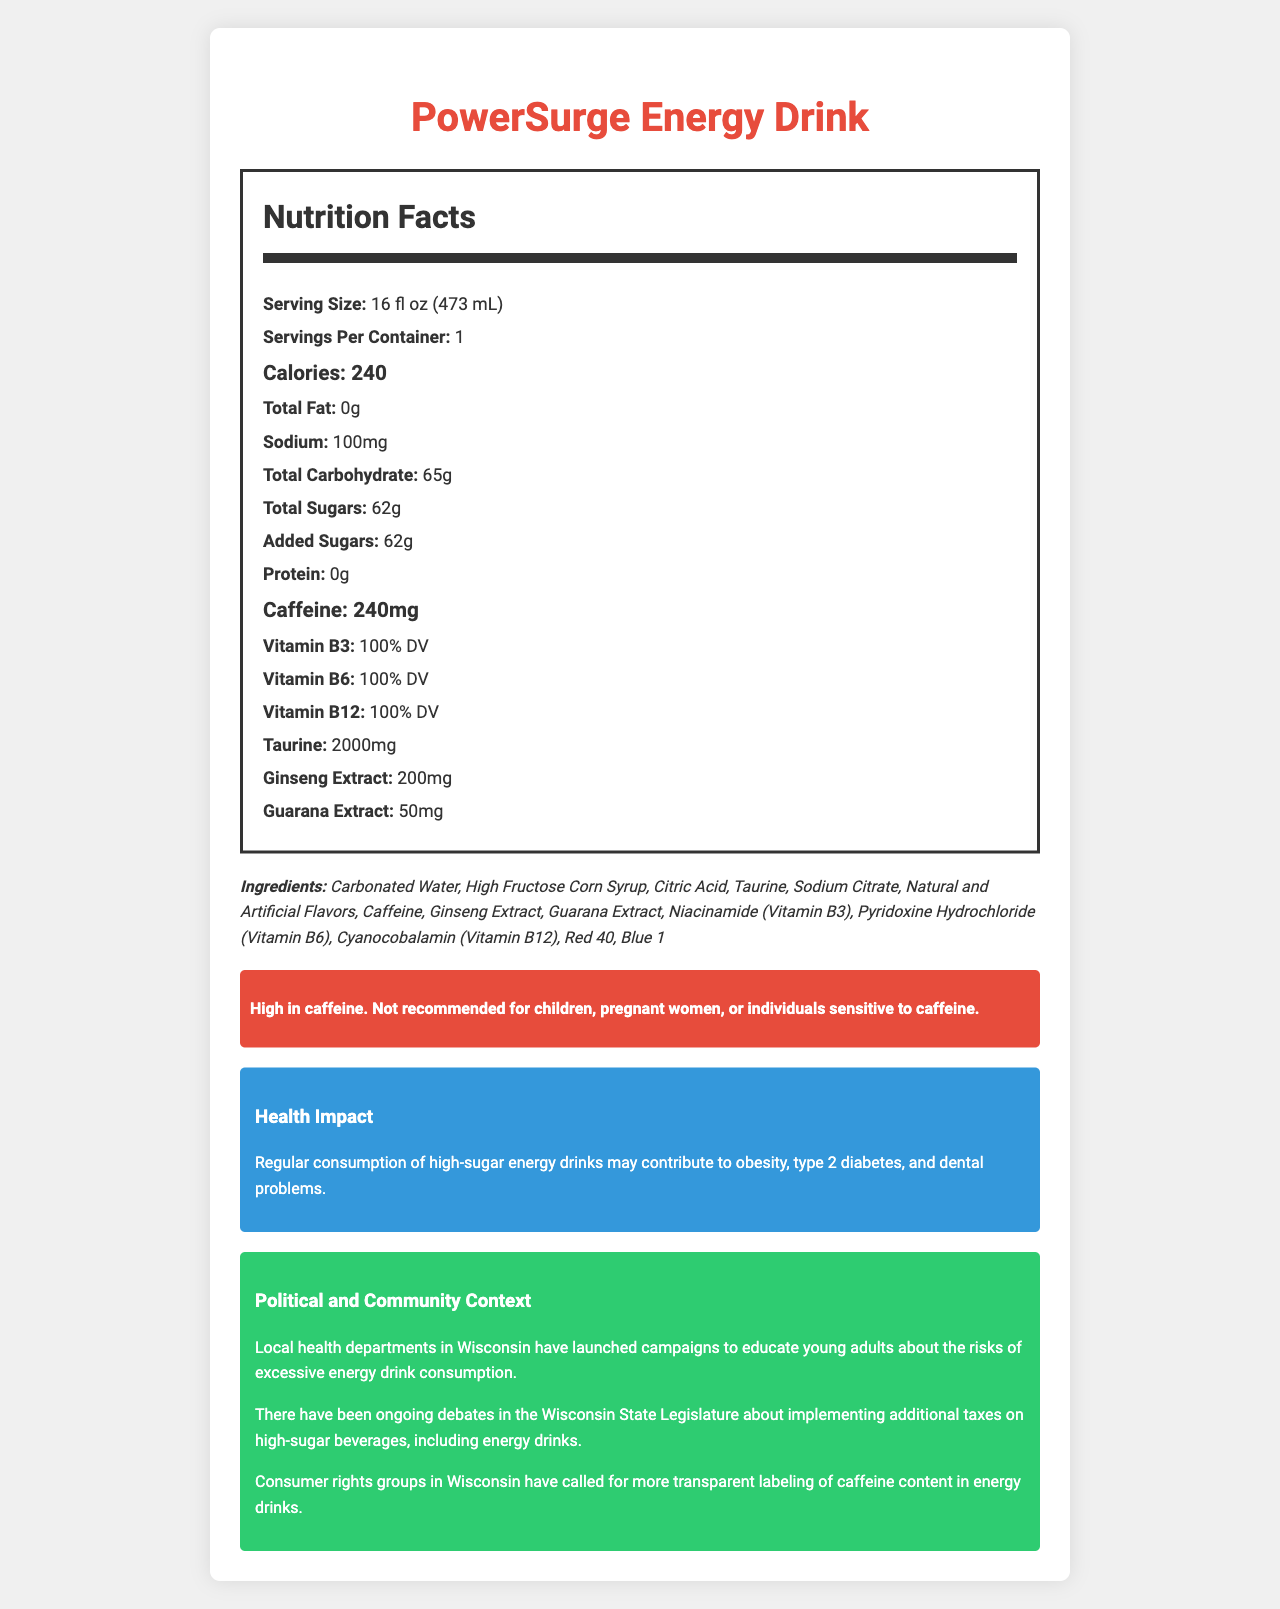what is the product name? The product name is listed at the top of the document under the heading.
Answer: PowerSurge Energy Drink what is the serving size of PowerSurge Energy Drink? The serving size is mentioned at the beginning of the Nutrition Facts section.
Answer: 16 fl oz (473 mL) how many calories are in one serving? The calories per serving are indicated as 240 in the Nutrition Facts section.
Answer: 240 what is the total amount of sugars in the drink? Both total sugars and added sugars are listed as 62g in the Nutrition Facts section.
Answer: 62g how much caffeine does the drink contain? The caffeine content is clearly specified as 240mg in the Nutrition Facts section.
Answer: 240mg which vitamins are present in PowerSurge Energy Drink? The vitamins present are listed as Vitamin B3 (100% DV), Vitamin B6 (100% DV), and Vitamin B12 (100% DV) in the Nutrition Facts section.
Answer: Vitamin B3, Vitamin B6, Vitamin B12 what is the sodium content of the drink? The sodium content is listed as 100mg in the Nutrition Facts section.
Answer: 100mg what are the potential health impacts of regular consumption of this energy drink? This information is provided in the Health Impact section of the document.
Answer: It may contribute to obesity, type 2 diabetes, and dental problems which of the following elements is NOT an ingredient in PowerSurge Energy Drink? A. Taurine B. Niacinamide C. Potassium Citrate D. High Fructose Corn Syrup Potassium Citrate is not listed among the ingredients. The other options are listed as ingredients.
Answer: C how many servings are there per container? A. 1 B. 2 C. 3 D. 4 It is stated that there is 1 serving per container in the Nutrition Facts section.
Answer: A is this drink recommended for children? The consumer alert specifically mentions that it is not recommended for children.
Answer: No what is the political context mentioned in the document? The political context discusses potential taxes on high-sugar beverages as seen in Wisconsin.
Answer: There have been debates in the Wisconsin State Legislature about implementing additional taxes on high-sugar beverages, including energy drinks summarize the main idea of this document. It provides a comprehensive overview of the drink's nutritional profile, potential health risks, and various societal aspects related to its consumption and regulation.
Answer: The document details the nutrition facts, ingredients, health impacts, and political context of PowerSurge Energy Drink, highlighting its high sugar and caffeine content and providing consumer alerts and advocacy information. what are the potential working conditions concerns related to energy drink manufacturers? This information is mentioned under the "workers rights concern" section in the document.
Answer: Some energy drink manufacturers have faced criticism for poor working conditions in their production facilities who are the advocacy groups calling for more transparent labeling of caffeine content? The document mentions that consumer rights groups in Wisconsin are calling for more transparent labeling of caffeine content in energy drinks.
Answer: Consumer rights groups in Wisconsin what color additives are included in the ingredients? The ingredients list includes Red 40 and Blue 1 as color additives.
Answer: Red 40, Blue 1 which extract is present in the highest quantity in PowerSurge Energy Drink? Taurine is listed as 2000mg, which is higher than the quantities for other extracts like ginseng and guarana.
Answer: Taurine how does the local health department in Wisconsin respond to energy drink consumption? This information is mentioned in the Community Health Initiative section of the document.
Answer: They have launched campaigns to educate young adults about the risks of excessive energy drink consumption what is the taurine content in PowerSurge Energy Drink? The taurine content is listed as 2000mg in the Nutrition Facts section.
Answer: 2000mg how does the production and disposal of energy drink cans affect the environment? This impact is mentioned under the Environmental Impact section of the document.
Answer: They contribute to environmental waste and carbon emissions what is the total carbohydrate content in the drink? The total carbohydrate content is labeled as 65g in the Nutrition Facts section.
Answer: 65g what is the correlation between high caffeine and certain health effects? The document does not provide enough correlation information to establish a relationship between high caffeine and specific health effects.
Answer: Not enough information 